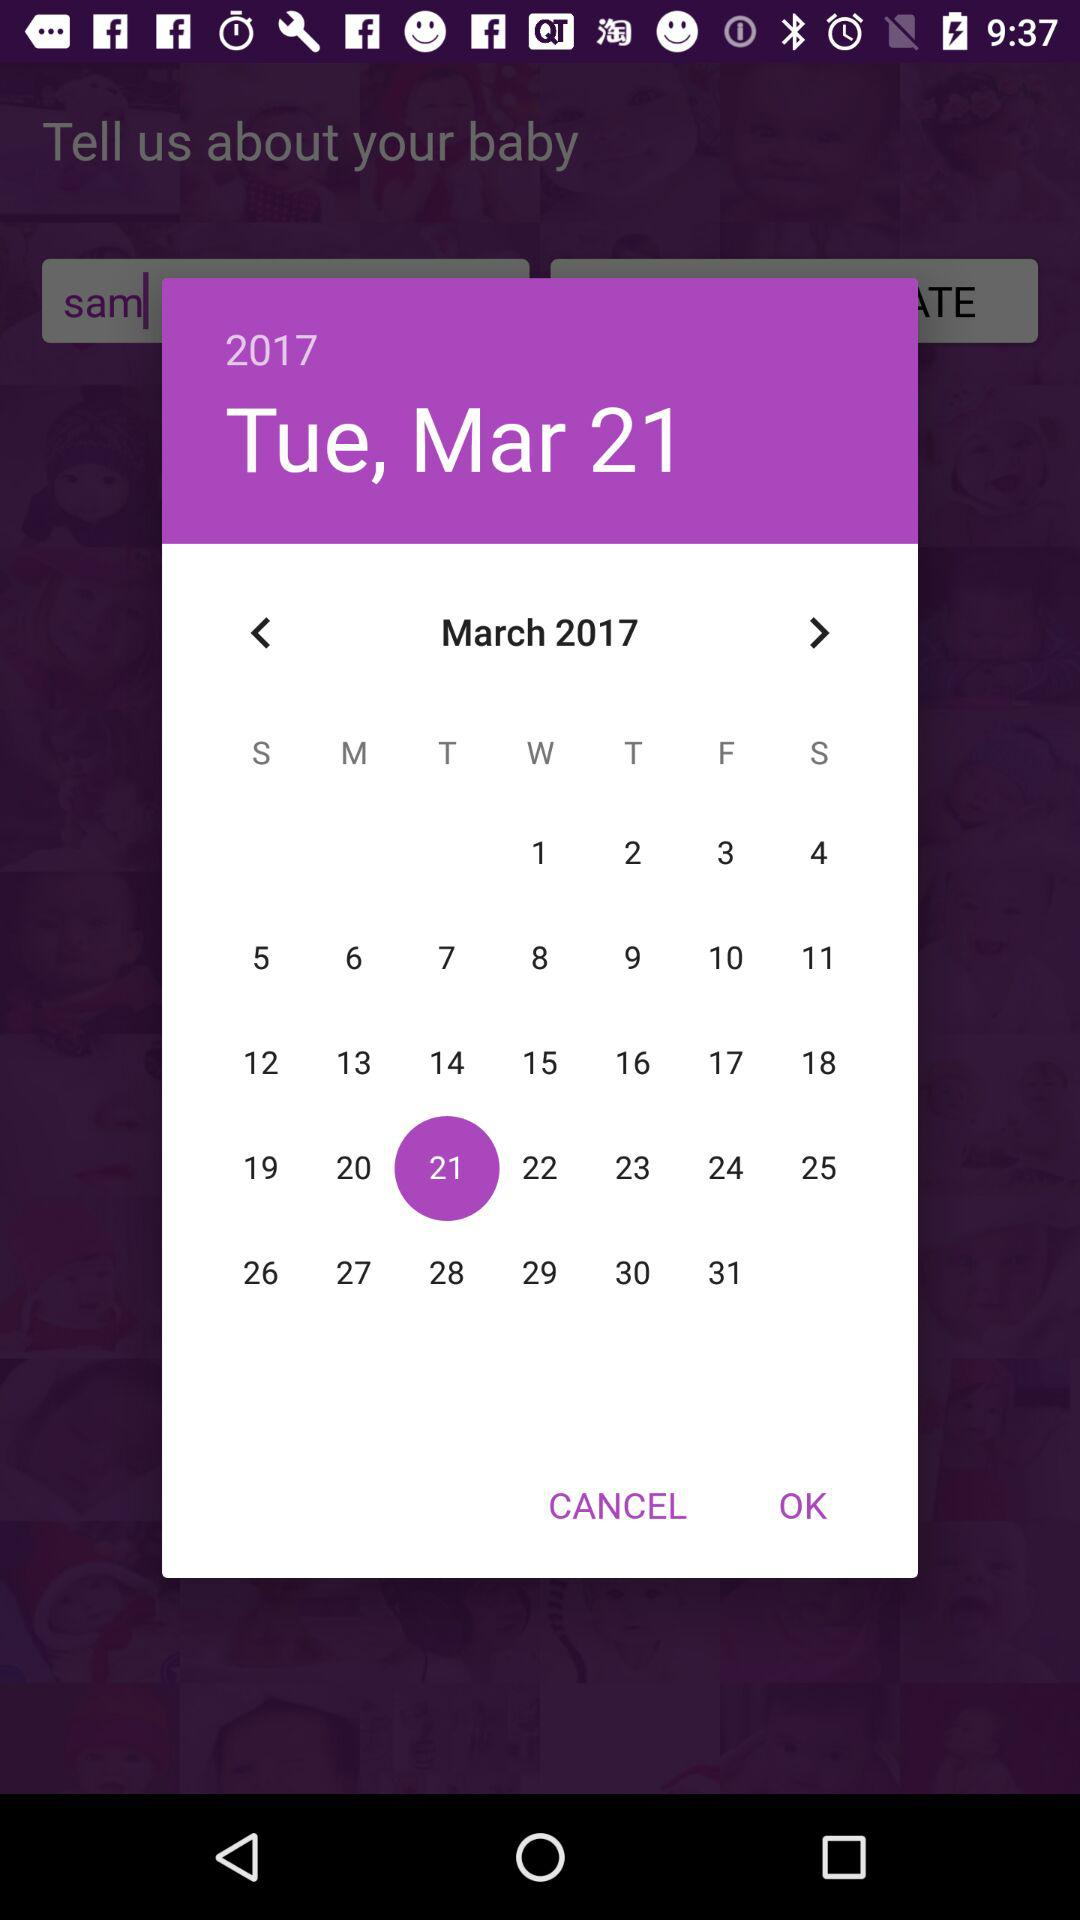What is the day on the selected date? The day is Tuesday. 